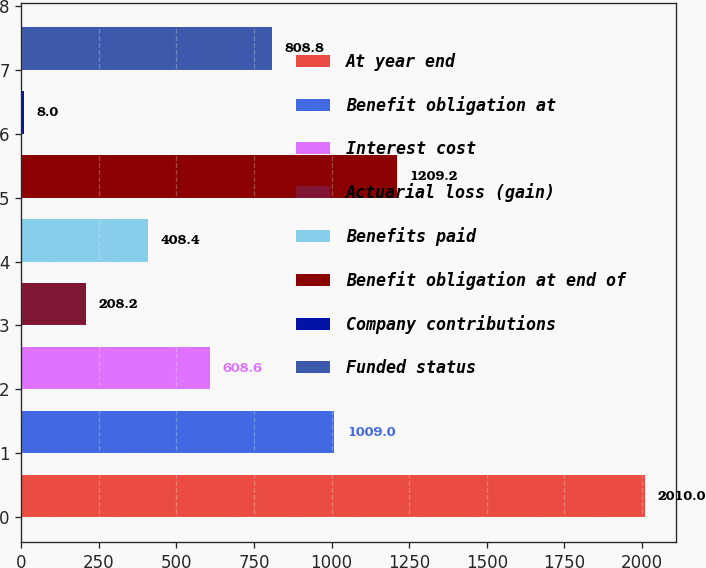<chart> <loc_0><loc_0><loc_500><loc_500><bar_chart><fcel>At year end<fcel>Benefit obligation at<fcel>Interest cost<fcel>Actuarial loss (gain)<fcel>Benefits paid<fcel>Benefit obligation at end of<fcel>Company contributions<fcel>Funded status<nl><fcel>2010<fcel>1009<fcel>608.6<fcel>208.2<fcel>408.4<fcel>1209.2<fcel>8<fcel>808.8<nl></chart> 